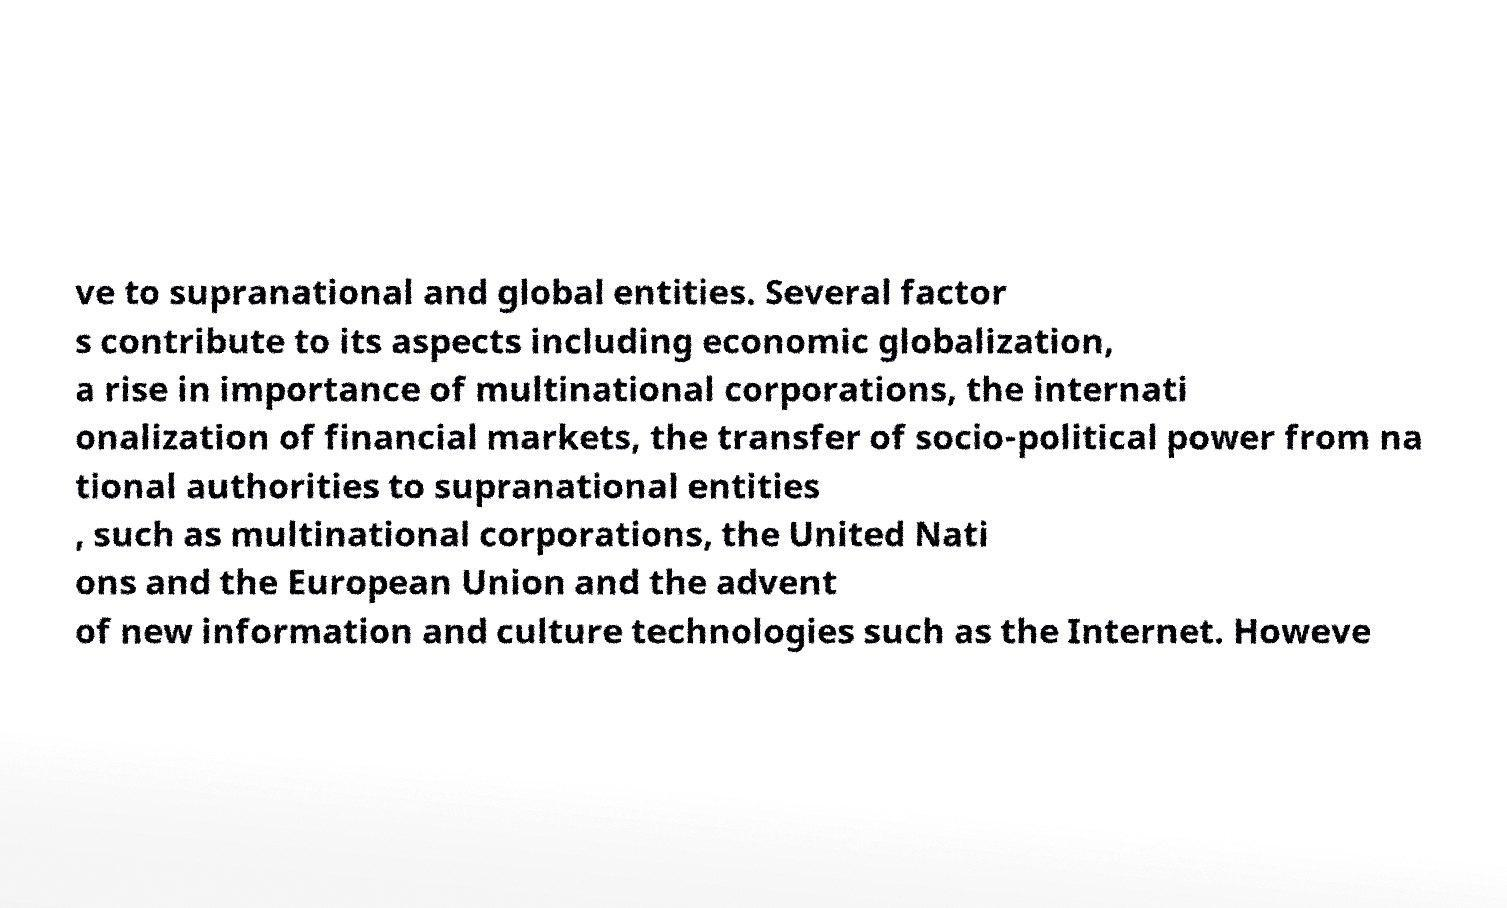Can you accurately transcribe the text from the provided image for me? ve to supranational and global entities. Several factor s contribute to its aspects including economic globalization, a rise in importance of multinational corporations, the internati onalization of financial markets, the transfer of socio-political power from na tional authorities to supranational entities , such as multinational corporations, the United Nati ons and the European Union and the advent of new information and culture technologies such as the Internet. Howeve 